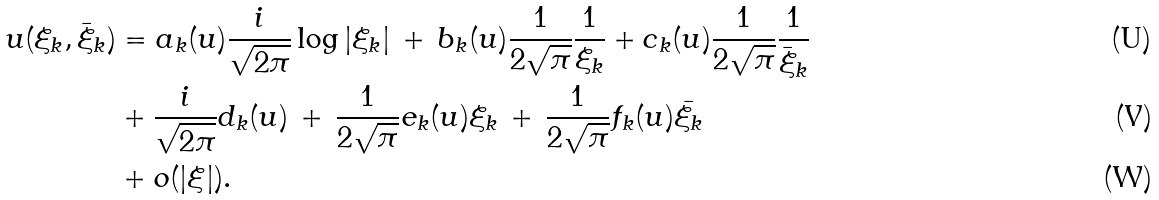Convert formula to latex. <formula><loc_0><loc_0><loc_500><loc_500>u ( \xi _ { k } , \bar { \xi } _ { k } ) & = a _ { k } ( u ) \frac { i } { \sqrt { 2 \pi } } \log | \xi _ { k } | \, + \, b _ { k } ( u ) \frac { 1 } { 2 \sqrt { \pi } } \frac { 1 } { \xi _ { k } } + c _ { k } ( u ) \frac { 1 } { 2 \sqrt { \pi } } \frac { 1 } { \bar { \xi } _ { k } } \\ & + \frac { i } { \sqrt { 2 \pi } } d _ { k } ( u ) \, + \, \frac { 1 } { 2 \sqrt { \pi } } e _ { k } ( u ) \xi _ { k } \, + \, \frac { 1 } { 2 \sqrt { \pi } } f _ { k } ( u ) \bar { \xi _ { k } } \, \\ & + o ( | \xi | ) .</formula> 